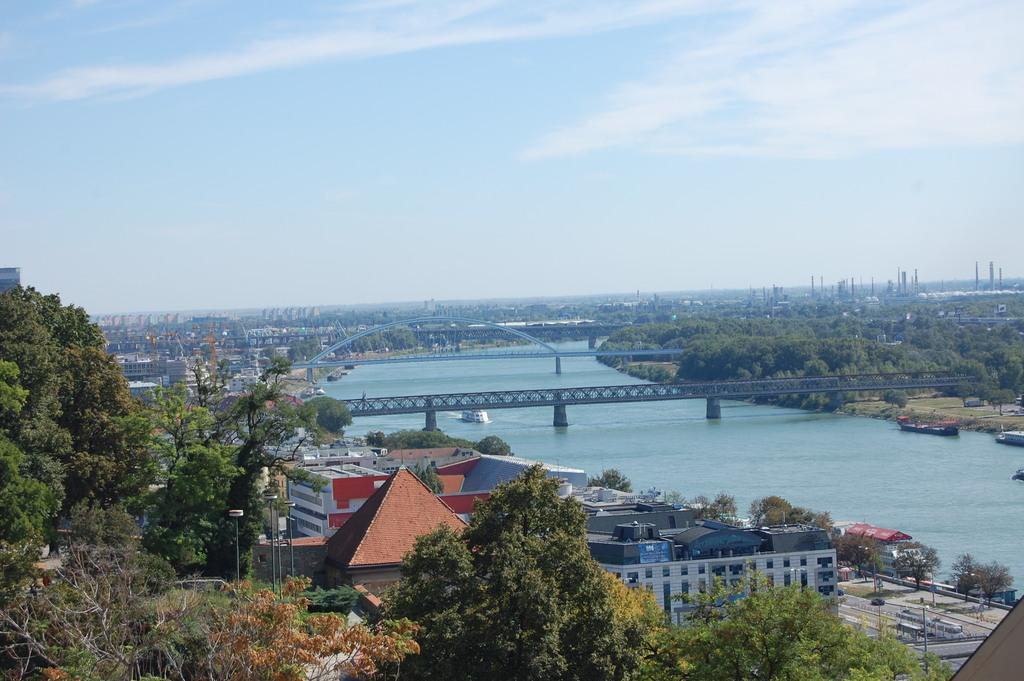What type of natural elements can be seen in the image? There are trees in the image. What type of man-made structures can be seen in the image? There are buildings, roads, poles, and bridges in the image. What type of transportation is visible in the image? There are ships above the water in the image. What part of the natural environment is visible in the image? The sky is visible at the top of the image. What type of wine is being served in the yard in the image? There is no wine or yard present in the image; it features trees, buildings, roads, poles, bridges, ships, and the sky. What hobbies are the people in the image engaged in? There are no people visible in the image, so their hobbies cannot be determined. 